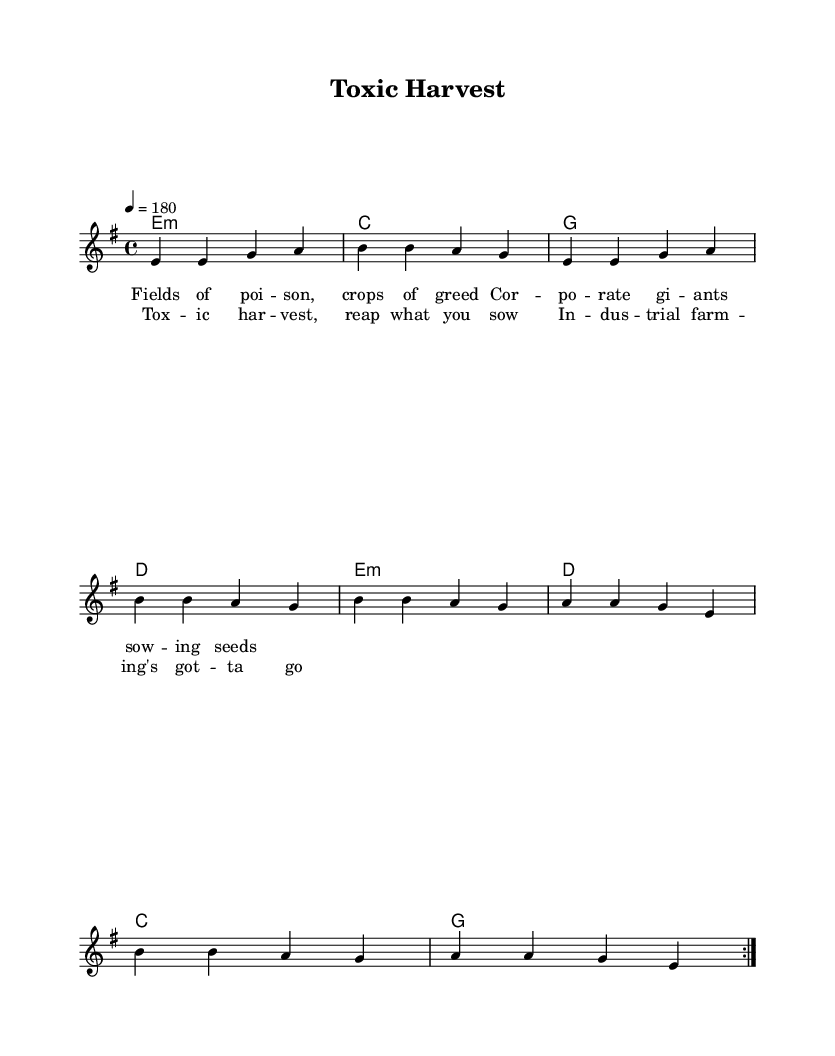What is the key signature of this music? The key signature is E minor, indicated by one sharp in the key signature at the beginning of the staff.
Answer: E minor What is the time signature of this music? The time signature is 4/4, which is stated at the beginning of the piece as the numerator is 4 (four beats per measure) and the denominator is 4 (quarter note beats).
Answer: 4/4 What is the tempo marking for this piece? The tempo marking is 180, indicated by "4 = 180" which shows the beats per minute for a quarter note.
Answer: 180 How many verses are repeated in this piece? The music specifies a repeat instruction "volt" which indicates that the section is repeated twice. This instruction generally applies to the entirety of the verse structure.
Answer: 2 What is the title of this piece? The title is prominently displayed at the top of the sheet music: "Toxic Harvest".
Answer: Toxic Harvest What message is conveyed in the lyrics of the chorus? The chorus critiques industrial farming by stating, "Toxic harvest, reap what you sow," implying negative consequences of industrial agriculture. This thematic content aligns with punk's critical and socially conscious focus.
Answer: Criticism of industrial farming Which instrument is primarily indicated by the sheet music? The primary instrument indicated in the score is a guitar, as seen in the chord names section that provides chord symbols for accompaniment.
Answer: Guitar 